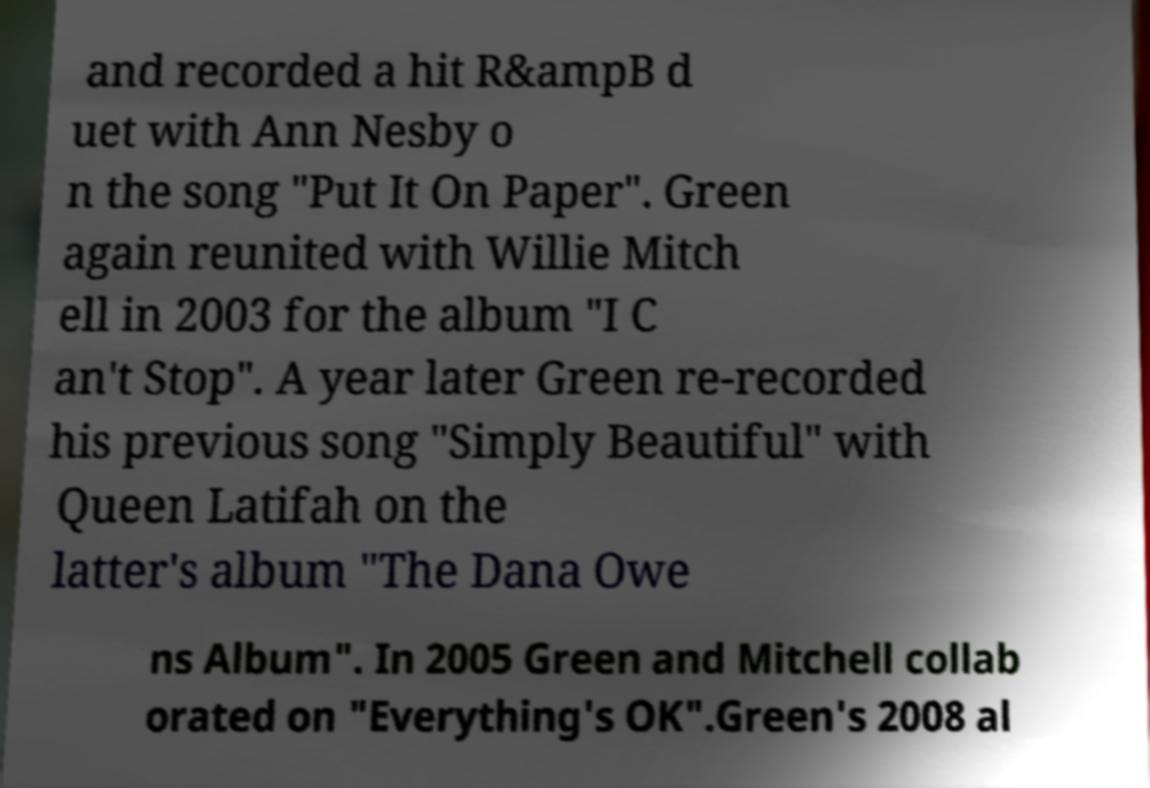Can you accurately transcribe the text from the provided image for me? and recorded a hit R&ampB d uet with Ann Nesby o n the song "Put It On Paper". Green again reunited with Willie Mitch ell in 2003 for the album "I C an't Stop". A year later Green re-recorded his previous song "Simply Beautiful" with Queen Latifah on the latter's album "The Dana Owe ns Album". In 2005 Green and Mitchell collab orated on "Everything's OK".Green's 2008 al 